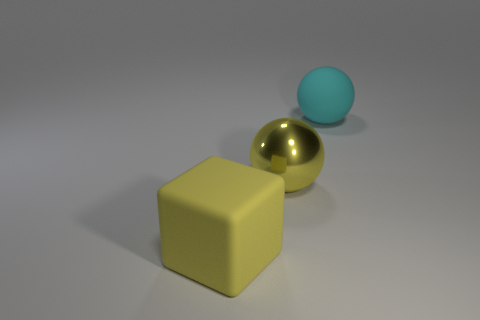Is there any other thing that is the same shape as the yellow rubber object?
Provide a succinct answer. No. Is the number of rubber things that are in front of the large metallic thing the same as the number of yellow things in front of the big yellow matte thing?
Offer a very short reply. No. Is there a sphere made of the same material as the block?
Your response must be concise. Yes. Is the large yellow thing on the left side of the large yellow ball made of the same material as the cyan object?
Give a very brief answer. Yes. What is the size of the thing that is right of the yellow matte thing and in front of the rubber ball?
Offer a terse response. Large. What is the color of the metallic object?
Give a very brief answer. Yellow. How many big yellow shiny balls are there?
Offer a terse response. 1. How many matte objects are the same color as the large metal object?
Keep it short and to the point. 1. Does the big matte thing on the right side of the big rubber block have the same shape as the big matte thing that is left of the yellow ball?
Ensure brevity in your answer.  No. What is the color of the big rubber object behind the yellow thing on the left side of the sphere that is in front of the cyan sphere?
Provide a short and direct response. Cyan. 